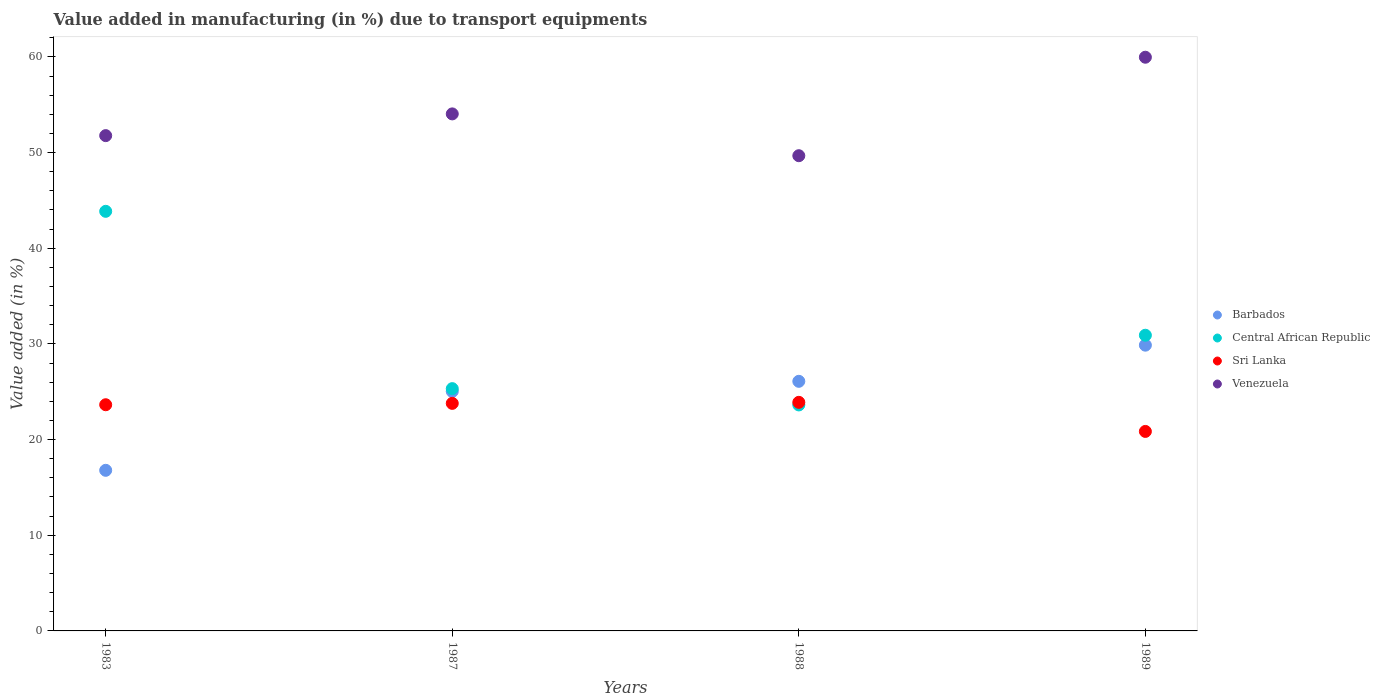Is the number of dotlines equal to the number of legend labels?
Your response must be concise. Yes. What is the percentage of value added in manufacturing due to transport equipments in Sri Lanka in 1988?
Keep it short and to the point. 23.89. Across all years, what is the maximum percentage of value added in manufacturing due to transport equipments in Venezuela?
Your answer should be very brief. 59.97. Across all years, what is the minimum percentage of value added in manufacturing due to transport equipments in Central African Republic?
Offer a very short reply. 23.62. In which year was the percentage of value added in manufacturing due to transport equipments in Barbados minimum?
Ensure brevity in your answer.  1983. What is the total percentage of value added in manufacturing due to transport equipments in Venezuela in the graph?
Give a very brief answer. 215.46. What is the difference between the percentage of value added in manufacturing due to transport equipments in Central African Republic in 1988 and that in 1989?
Offer a very short reply. -7.28. What is the difference between the percentage of value added in manufacturing due to transport equipments in Sri Lanka in 1988 and the percentage of value added in manufacturing due to transport equipments in Barbados in 1987?
Give a very brief answer. -1.14. What is the average percentage of value added in manufacturing due to transport equipments in Sri Lanka per year?
Your response must be concise. 23.04. In the year 1989, what is the difference between the percentage of value added in manufacturing due to transport equipments in Central African Republic and percentage of value added in manufacturing due to transport equipments in Barbados?
Give a very brief answer. 1.04. What is the ratio of the percentage of value added in manufacturing due to transport equipments in Venezuela in 1983 to that in 1988?
Make the answer very short. 1.04. Is the difference between the percentage of value added in manufacturing due to transport equipments in Central African Republic in 1983 and 1988 greater than the difference between the percentage of value added in manufacturing due to transport equipments in Barbados in 1983 and 1988?
Your answer should be compact. Yes. What is the difference between the highest and the second highest percentage of value added in manufacturing due to transport equipments in Barbados?
Make the answer very short. 3.78. What is the difference between the highest and the lowest percentage of value added in manufacturing due to transport equipments in Central African Republic?
Keep it short and to the point. 20.24. In how many years, is the percentage of value added in manufacturing due to transport equipments in Sri Lanka greater than the average percentage of value added in manufacturing due to transport equipments in Sri Lanka taken over all years?
Keep it short and to the point. 3. Is the sum of the percentage of value added in manufacturing due to transport equipments in Venezuela in 1983 and 1987 greater than the maximum percentage of value added in manufacturing due to transport equipments in Sri Lanka across all years?
Offer a terse response. Yes. Is it the case that in every year, the sum of the percentage of value added in manufacturing due to transport equipments in Barbados and percentage of value added in manufacturing due to transport equipments in Venezuela  is greater than the sum of percentage of value added in manufacturing due to transport equipments in Sri Lanka and percentage of value added in manufacturing due to transport equipments in Central African Republic?
Offer a terse response. Yes. Is the percentage of value added in manufacturing due to transport equipments in Central African Republic strictly less than the percentage of value added in manufacturing due to transport equipments in Sri Lanka over the years?
Provide a succinct answer. No. How many years are there in the graph?
Provide a short and direct response. 4. What is the difference between two consecutive major ticks on the Y-axis?
Offer a terse response. 10. Are the values on the major ticks of Y-axis written in scientific E-notation?
Your answer should be very brief. No. Does the graph contain grids?
Give a very brief answer. No. Where does the legend appear in the graph?
Your response must be concise. Center right. How are the legend labels stacked?
Provide a short and direct response. Vertical. What is the title of the graph?
Your answer should be compact. Value added in manufacturing (in %) due to transport equipments. Does "Uruguay" appear as one of the legend labels in the graph?
Give a very brief answer. No. What is the label or title of the Y-axis?
Make the answer very short. Value added (in %). What is the Value added (in %) of Barbados in 1983?
Offer a terse response. 16.79. What is the Value added (in %) in Central African Republic in 1983?
Your answer should be very brief. 43.86. What is the Value added (in %) in Sri Lanka in 1983?
Your answer should be very brief. 23.64. What is the Value added (in %) of Venezuela in 1983?
Offer a terse response. 51.77. What is the Value added (in %) in Barbados in 1987?
Offer a terse response. 25.04. What is the Value added (in %) of Central African Republic in 1987?
Offer a very short reply. 25.33. What is the Value added (in %) in Sri Lanka in 1987?
Provide a succinct answer. 23.79. What is the Value added (in %) of Venezuela in 1987?
Provide a short and direct response. 54.04. What is the Value added (in %) in Barbados in 1988?
Provide a succinct answer. 26.09. What is the Value added (in %) of Central African Republic in 1988?
Ensure brevity in your answer.  23.62. What is the Value added (in %) of Sri Lanka in 1988?
Ensure brevity in your answer.  23.89. What is the Value added (in %) of Venezuela in 1988?
Offer a very short reply. 49.67. What is the Value added (in %) of Barbados in 1989?
Offer a terse response. 29.87. What is the Value added (in %) in Central African Republic in 1989?
Offer a terse response. 30.91. What is the Value added (in %) in Sri Lanka in 1989?
Give a very brief answer. 20.85. What is the Value added (in %) of Venezuela in 1989?
Your response must be concise. 59.97. Across all years, what is the maximum Value added (in %) of Barbados?
Offer a very short reply. 29.87. Across all years, what is the maximum Value added (in %) in Central African Republic?
Offer a very short reply. 43.86. Across all years, what is the maximum Value added (in %) of Sri Lanka?
Keep it short and to the point. 23.89. Across all years, what is the maximum Value added (in %) in Venezuela?
Your answer should be very brief. 59.97. Across all years, what is the minimum Value added (in %) of Barbados?
Offer a very short reply. 16.79. Across all years, what is the minimum Value added (in %) in Central African Republic?
Give a very brief answer. 23.62. Across all years, what is the minimum Value added (in %) in Sri Lanka?
Your answer should be very brief. 20.85. Across all years, what is the minimum Value added (in %) in Venezuela?
Provide a short and direct response. 49.67. What is the total Value added (in %) in Barbados in the graph?
Offer a very short reply. 97.79. What is the total Value added (in %) of Central African Republic in the graph?
Your response must be concise. 123.72. What is the total Value added (in %) of Sri Lanka in the graph?
Your answer should be compact. 92.18. What is the total Value added (in %) in Venezuela in the graph?
Your answer should be compact. 215.46. What is the difference between the Value added (in %) in Barbados in 1983 and that in 1987?
Your response must be concise. -8.25. What is the difference between the Value added (in %) in Central African Republic in 1983 and that in 1987?
Your answer should be compact. 18.53. What is the difference between the Value added (in %) in Sri Lanka in 1983 and that in 1987?
Make the answer very short. -0.14. What is the difference between the Value added (in %) of Venezuela in 1983 and that in 1987?
Give a very brief answer. -2.27. What is the difference between the Value added (in %) of Barbados in 1983 and that in 1988?
Make the answer very short. -9.3. What is the difference between the Value added (in %) in Central African Republic in 1983 and that in 1988?
Keep it short and to the point. 20.24. What is the difference between the Value added (in %) in Sri Lanka in 1983 and that in 1988?
Offer a terse response. -0.25. What is the difference between the Value added (in %) in Venezuela in 1983 and that in 1988?
Make the answer very short. 2.1. What is the difference between the Value added (in %) of Barbados in 1983 and that in 1989?
Keep it short and to the point. -13.08. What is the difference between the Value added (in %) in Central African Republic in 1983 and that in 1989?
Your answer should be very brief. 12.95. What is the difference between the Value added (in %) of Sri Lanka in 1983 and that in 1989?
Your answer should be compact. 2.79. What is the difference between the Value added (in %) in Venezuela in 1983 and that in 1989?
Ensure brevity in your answer.  -8.2. What is the difference between the Value added (in %) in Barbados in 1987 and that in 1988?
Provide a short and direct response. -1.05. What is the difference between the Value added (in %) in Central African Republic in 1987 and that in 1988?
Keep it short and to the point. 1.7. What is the difference between the Value added (in %) in Sri Lanka in 1987 and that in 1988?
Ensure brevity in your answer.  -0.11. What is the difference between the Value added (in %) in Venezuela in 1987 and that in 1988?
Your answer should be very brief. 4.37. What is the difference between the Value added (in %) of Barbados in 1987 and that in 1989?
Give a very brief answer. -4.83. What is the difference between the Value added (in %) of Central African Republic in 1987 and that in 1989?
Your answer should be compact. -5.58. What is the difference between the Value added (in %) in Sri Lanka in 1987 and that in 1989?
Offer a terse response. 2.93. What is the difference between the Value added (in %) in Venezuela in 1987 and that in 1989?
Provide a short and direct response. -5.92. What is the difference between the Value added (in %) of Barbados in 1988 and that in 1989?
Offer a terse response. -3.78. What is the difference between the Value added (in %) of Central African Republic in 1988 and that in 1989?
Your response must be concise. -7.28. What is the difference between the Value added (in %) in Sri Lanka in 1988 and that in 1989?
Give a very brief answer. 3.04. What is the difference between the Value added (in %) in Venezuela in 1988 and that in 1989?
Ensure brevity in your answer.  -10.29. What is the difference between the Value added (in %) of Barbados in 1983 and the Value added (in %) of Central African Republic in 1987?
Keep it short and to the point. -8.54. What is the difference between the Value added (in %) in Barbados in 1983 and the Value added (in %) in Sri Lanka in 1987?
Your response must be concise. -7. What is the difference between the Value added (in %) in Barbados in 1983 and the Value added (in %) in Venezuela in 1987?
Offer a terse response. -37.26. What is the difference between the Value added (in %) of Central African Republic in 1983 and the Value added (in %) of Sri Lanka in 1987?
Your answer should be compact. 20.07. What is the difference between the Value added (in %) in Central African Republic in 1983 and the Value added (in %) in Venezuela in 1987?
Provide a succinct answer. -10.18. What is the difference between the Value added (in %) in Sri Lanka in 1983 and the Value added (in %) in Venezuela in 1987?
Provide a succinct answer. -30.4. What is the difference between the Value added (in %) of Barbados in 1983 and the Value added (in %) of Central African Republic in 1988?
Ensure brevity in your answer.  -6.83. What is the difference between the Value added (in %) of Barbados in 1983 and the Value added (in %) of Sri Lanka in 1988?
Make the answer very short. -7.11. What is the difference between the Value added (in %) in Barbados in 1983 and the Value added (in %) in Venezuela in 1988?
Make the answer very short. -32.89. What is the difference between the Value added (in %) of Central African Republic in 1983 and the Value added (in %) of Sri Lanka in 1988?
Offer a very short reply. 19.97. What is the difference between the Value added (in %) of Central African Republic in 1983 and the Value added (in %) of Venezuela in 1988?
Provide a short and direct response. -5.81. What is the difference between the Value added (in %) in Sri Lanka in 1983 and the Value added (in %) in Venezuela in 1988?
Make the answer very short. -26.03. What is the difference between the Value added (in %) in Barbados in 1983 and the Value added (in %) in Central African Republic in 1989?
Your response must be concise. -14.12. What is the difference between the Value added (in %) in Barbados in 1983 and the Value added (in %) in Sri Lanka in 1989?
Offer a very short reply. -4.07. What is the difference between the Value added (in %) of Barbados in 1983 and the Value added (in %) of Venezuela in 1989?
Your answer should be very brief. -43.18. What is the difference between the Value added (in %) in Central African Republic in 1983 and the Value added (in %) in Sri Lanka in 1989?
Your answer should be very brief. 23.01. What is the difference between the Value added (in %) of Central African Republic in 1983 and the Value added (in %) of Venezuela in 1989?
Give a very brief answer. -16.11. What is the difference between the Value added (in %) in Sri Lanka in 1983 and the Value added (in %) in Venezuela in 1989?
Provide a short and direct response. -36.32. What is the difference between the Value added (in %) in Barbados in 1987 and the Value added (in %) in Central African Republic in 1988?
Provide a short and direct response. 1.41. What is the difference between the Value added (in %) in Barbados in 1987 and the Value added (in %) in Sri Lanka in 1988?
Give a very brief answer. 1.14. What is the difference between the Value added (in %) in Barbados in 1987 and the Value added (in %) in Venezuela in 1988?
Your answer should be compact. -24.64. What is the difference between the Value added (in %) in Central African Republic in 1987 and the Value added (in %) in Sri Lanka in 1988?
Your answer should be compact. 1.43. What is the difference between the Value added (in %) of Central African Republic in 1987 and the Value added (in %) of Venezuela in 1988?
Provide a short and direct response. -24.35. What is the difference between the Value added (in %) in Sri Lanka in 1987 and the Value added (in %) in Venezuela in 1988?
Your answer should be compact. -25.89. What is the difference between the Value added (in %) in Barbados in 1987 and the Value added (in %) in Central African Republic in 1989?
Ensure brevity in your answer.  -5.87. What is the difference between the Value added (in %) of Barbados in 1987 and the Value added (in %) of Sri Lanka in 1989?
Make the answer very short. 4.18. What is the difference between the Value added (in %) of Barbados in 1987 and the Value added (in %) of Venezuela in 1989?
Your response must be concise. -34.93. What is the difference between the Value added (in %) of Central African Republic in 1987 and the Value added (in %) of Sri Lanka in 1989?
Make the answer very short. 4.47. What is the difference between the Value added (in %) in Central African Republic in 1987 and the Value added (in %) in Venezuela in 1989?
Your answer should be very brief. -34.64. What is the difference between the Value added (in %) of Sri Lanka in 1987 and the Value added (in %) of Venezuela in 1989?
Offer a very short reply. -36.18. What is the difference between the Value added (in %) of Barbados in 1988 and the Value added (in %) of Central African Republic in 1989?
Ensure brevity in your answer.  -4.82. What is the difference between the Value added (in %) of Barbados in 1988 and the Value added (in %) of Sri Lanka in 1989?
Provide a succinct answer. 5.24. What is the difference between the Value added (in %) in Barbados in 1988 and the Value added (in %) in Venezuela in 1989?
Keep it short and to the point. -33.88. What is the difference between the Value added (in %) in Central African Republic in 1988 and the Value added (in %) in Sri Lanka in 1989?
Offer a terse response. 2.77. What is the difference between the Value added (in %) in Central African Republic in 1988 and the Value added (in %) in Venezuela in 1989?
Provide a succinct answer. -36.34. What is the difference between the Value added (in %) of Sri Lanka in 1988 and the Value added (in %) of Venezuela in 1989?
Your answer should be compact. -36.07. What is the average Value added (in %) in Barbados per year?
Keep it short and to the point. 24.45. What is the average Value added (in %) of Central African Republic per year?
Your response must be concise. 30.93. What is the average Value added (in %) of Sri Lanka per year?
Ensure brevity in your answer.  23.04. What is the average Value added (in %) of Venezuela per year?
Your answer should be compact. 53.86. In the year 1983, what is the difference between the Value added (in %) in Barbados and Value added (in %) in Central African Republic?
Your answer should be compact. -27.07. In the year 1983, what is the difference between the Value added (in %) in Barbados and Value added (in %) in Sri Lanka?
Your answer should be compact. -6.86. In the year 1983, what is the difference between the Value added (in %) of Barbados and Value added (in %) of Venezuela?
Provide a short and direct response. -34.98. In the year 1983, what is the difference between the Value added (in %) in Central African Republic and Value added (in %) in Sri Lanka?
Give a very brief answer. 20.22. In the year 1983, what is the difference between the Value added (in %) in Central African Republic and Value added (in %) in Venezuela?
Your response must be concise. -7.91. In the year 1983, what is the difference between the Value added (in %) of Sri Lanka and Value added (in %) of Venezuela?
Provide a short and direct response. -28.13. In the year 1987, what is the difference between the Value added (in %) of Barbados and Value added (in %) of Central African Republic?
Offer a very short reply. -0.29. In the year 1987, what is the difference between the Value added (in %) of Barbados and Value added (in %) of Sri Lanka?
Give a very brief answer. 1.25. In the year 1987, what is the difference between the Value added (in %) of Barbados and Value added (in %) of Venezuela?
Make the answer very short. -29.01. In the year 1987, what is the difference between the Value added (in %) of Central African Republic and Value added (in %) of Sri Lanka?
Provide a short and direct response. 1.54. In the year 1987, what is the difference between the Value added (in %) of Central African Republic and Value added (in %) of Venezuela?
Make the answer very short. -28.72. In the year 1987, what is the difference between the Value added (in %) of Sri Lanka and Value added (in %) of Venezuela?
Keep it short and to the point. -30.26. In the year 1988, what is the difference between the Value added (in %) of Barbados and Value added (in %) of Central African Republic?
Your answer should be very brief. 2.47. In the year 1988, what is the difference between the Value added (in %) in Barbados and Value added (in %) in Sri Lanka?
Offer a very short reply. 2.2. In the year 1988, what is the difference between the Value added (in %) in Barbados and Value added (in %) in Venezuela?
Your answer should be compact. -23.58. In the year 1988, what is the difference between the Value added (in %) of Central African Republic and Value added (in %) of Sri Lanka?
Provide a succinct answer. -0.27. In the year 1988, what is the difference between the Value added (in %) in Central African Republic and Value added (in %) in Venezuela?
Your answer should be compact. -26.05. In the year 1988, what is the difference between the Value added (in %) in Sri Lanka and Value added (in %) in Venezuela?
Your answer should be very brief. -25.78. In the year 1989, what is the difference between the Value added (in %) in Barbados and Value added (in %) in Central African Republic?
Your answer should be compact. -1.04. In the year 1989, what is the difference between the Value added (in %) in Barbados and Value added (in %) in Sri Lanka?
Provide a succinct answer. 9.02. In the year 1989, what is the difference between the Value added (in %) in Barbados and Value added (in %) in Venezuela?
Provide a short and direct response. -30.1. In the year 1989, what is the difference between the Value added (in %) of Central African Republic and Value added (in %) of Sri Lanka?
Provide a succinct answer. 10.05. In the year 1989, what is the difference between the Value added (in %) of Central African Republic and Value added (in %) of Venezuela?
Offer a very short reply. -29.06. In the year 1989, what is the difference between the Value added (in %) of Sri Lanka and Value added (in %) of Venezuela?
Provide a succinct answer. -39.11. What is the ratio of the Value added (in %) in Barbados in 1983 to that in 1987?
Keep it short and to the point. 0.67. What is the ratio of the Value added (in %) of Central African Republic in 1983 to that in 1987?
Give a very brief answer. 1.73. What is the ratio of the Value added (in %) in Venezuela in 1983 to that in 1987?
Your answer should be compact. 0.96. What is the ratio of the Value added (in %) of Barbados in 1983 to that in 1988?
Offer a terse response. 0.64. What is the ratio of the Value added (in %) in Central African Republic in 1983 to that in 1988?
Offer a terse response. 1.86. What is the ratio of the Value added (in %) in Sri Lanka in 1983 to that in 1988?
Your response must be concise. 0.99. What is the ratio of the Value added (in %) in Venezuela in 1983 to that in 1988?
Make the answer very short. 1.04. What is the ratio of the Value added (in %) in Barbados in 1983 to that in 1989?
Your response must be concise. 0.56. What is the ratio of the Value added (in %) in Central African Republic in 1983 to that in 1989?
Ensure brevity in your answer.  1.42. What is the ratio of the Value added (in %) of Sri Lanka in 1983 to that in 1989?
Give a very brief answer. 1.13. What is the ratio of the Value added (in %) of Venezuela in 1983 to that in 1989?
Keep it short and to the point. 0.86. What is the ratio of the Value added (in %) of Barbados in 1987 to that in 1988?
Offer a terse response. 0.96. What is the ratio of the Value added (in %) of Central African Republic in 1987 to that in 1988?
Give a very brief answer. 1.07. What is the ratio of the Value added (in %) in Venezuela in 1987 to that in 1988?
Your response must be concise. 1.09. What is the ratio of the Value added (in %) in Barbados in 1987 to that in 1989?
Provide a succinct answer. 0.84. What is the ratio of the Value added (in %) in Central African Republic in 1987 to that in 1989?
Your answer should be compact. 0.82. What is the ratio of the Value added (in %) in Sri Lanka in 1987 to that in 1989?
Make the answer very short. 1.14. What is the ratio of the Value added (in %) in Venezuela in 1987 to that in 1989?
Provide a short and direct response. 0.9. What is the ratio of the Value added (in %) of Barbados in 1988 to that in 1989?
Offer a very short reply. 0.87. What is the ratio of the Value added (in %) of Central African Republic in 1988 to that in 1989?
Provide a succinct answer. 0.76. What is the ratio of the Value added (in %) of Sri Lanka in 1988 to that in 1989?
Ensure brevity in your answer.  1.15. What is the ratio of the Value added (in %) in Venezuela in 1988 to that in 1989?
Keep it short and to the point. 0.83. What is the difference between the highest and the second highest Value added (in %) of Barbados?
Ensure brevity in your answer.  3.78. What is the difference between the highest and the second highest Value added (in %) of Central African Republic?
Offer a very short reply. 12.95. What is the difference between the highest and the second highest Value added (in %) of Sri Lanka?
Keep it short and to the point. 0.11. What is the difference between the highest and the second highest Value added (in %) in Venezuela?
Your answer should be very brief. 5.92. What is the difference between the highest and the lowest Value added (in %) in Barbados?
Offer a very short reply. 13.08. What is the difference between the highest and the lowest Value added (in %) in Central African Republic?
Your answer should be compact. 20.24. What is the difference between the highest and the lowest Value added (in %) of Sri Lanka?
Provide a short and direct response. 3.04. What is the difference between the highest and the lowest Value added (in %) in Venezuela?
Your answer should be very brief. 10.29. 